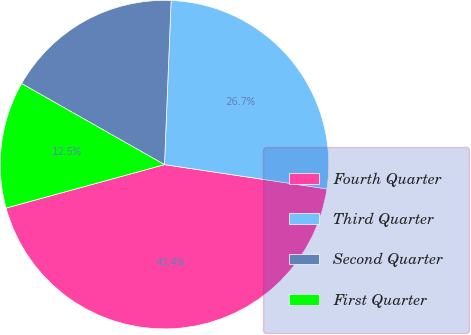Convert chart. <chart><loc_0><loc_0><loc_500><loc_500><pie_chart><fcel>Fourth Quarter<fcel>Third Quarter<fcel>Second Quarter<fcel>First Quarter<nl><fcel>43.38%<fcel>26.72%<fcel>17.43%<fcel>12.47%<nl></chart> 